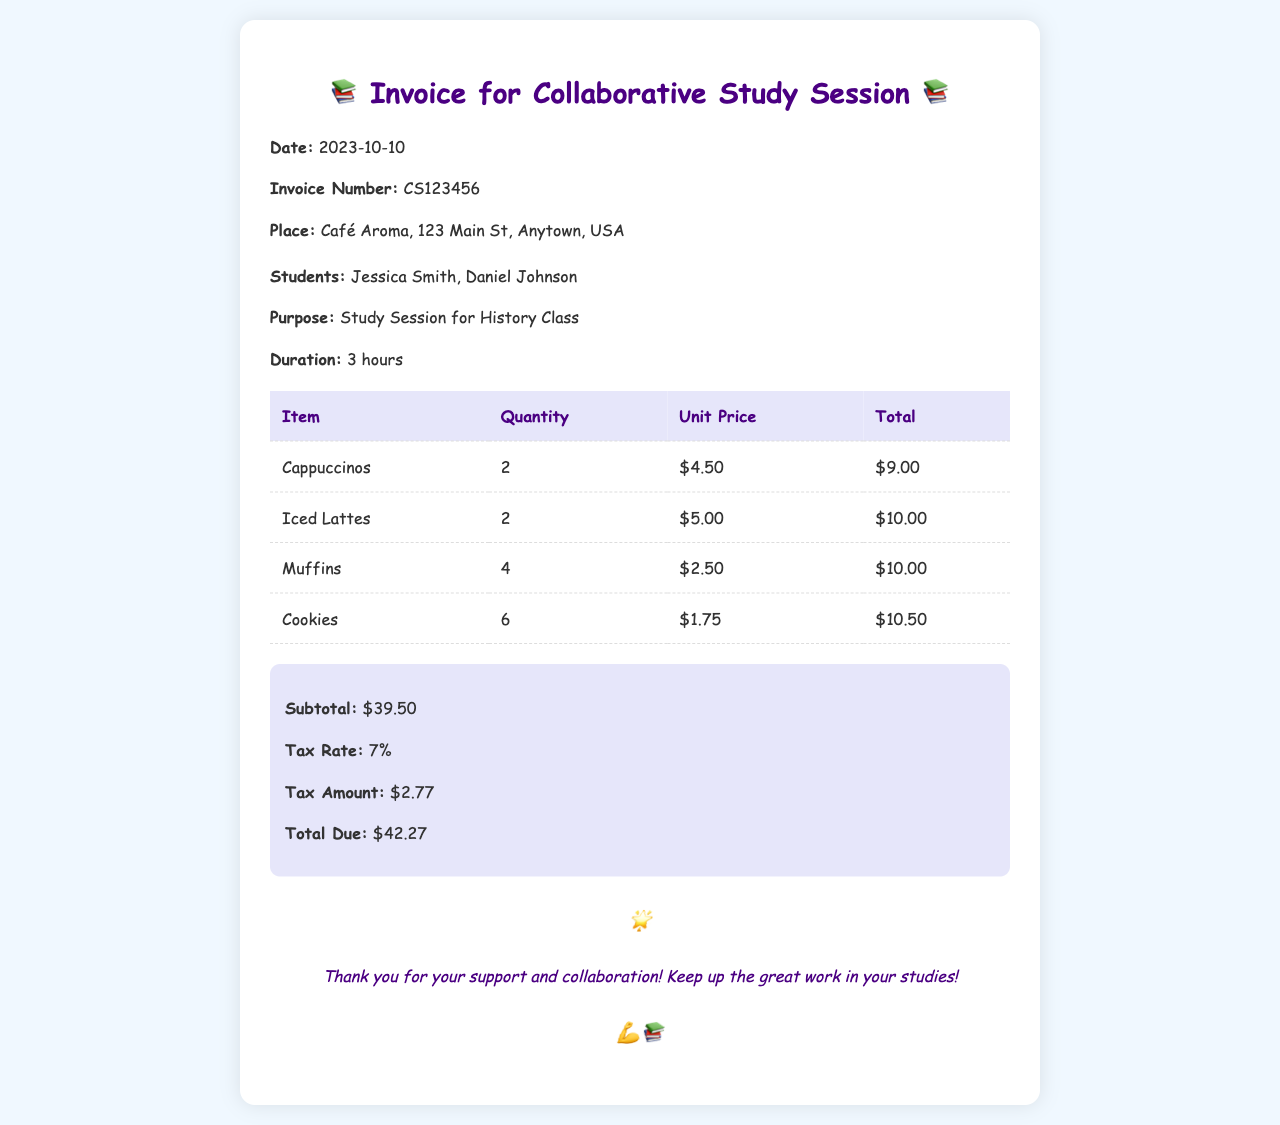What is the invoice number? The invoice number is clearly stated in the document as a unique identifier for this invoice.
Answer: CS123456 What is the date of the study session? The date is mentioned at the top of the invoice, indicating when the session took place.
Answer: 2023-10-10 How many students are listed in the details? The document specifies the number of students involved in the study session.
Answer: 2 What is the total due amount? The total due amount is the final figure presented at the end of the summary.
Answer: $42.27 What items are included in the expenses? The invoice provides a detailed list of all items that were purchased during the study session.
Answer: Cappuccinos, Iced Lattes, Muffins, Cookies What is the subtotal before tax? The subtotal is the sum of all expenses before tax is applied, giving a clear figure of expenses.
Answer: $39.50 Which item had the highest quantity ordered? By examining the quantities of all items, you can identify the item with the highest number purchased.
Answer: Cookies What is the tax rate applied to the invoice? The tax rate is explicitly mentioned in the summary section of the invoice.
Answer: 7% What is the purpose of the study session? The purpose is clearly stated in the details, giving insight into the reason for the meeting.
Answer: Study Session for History Class 